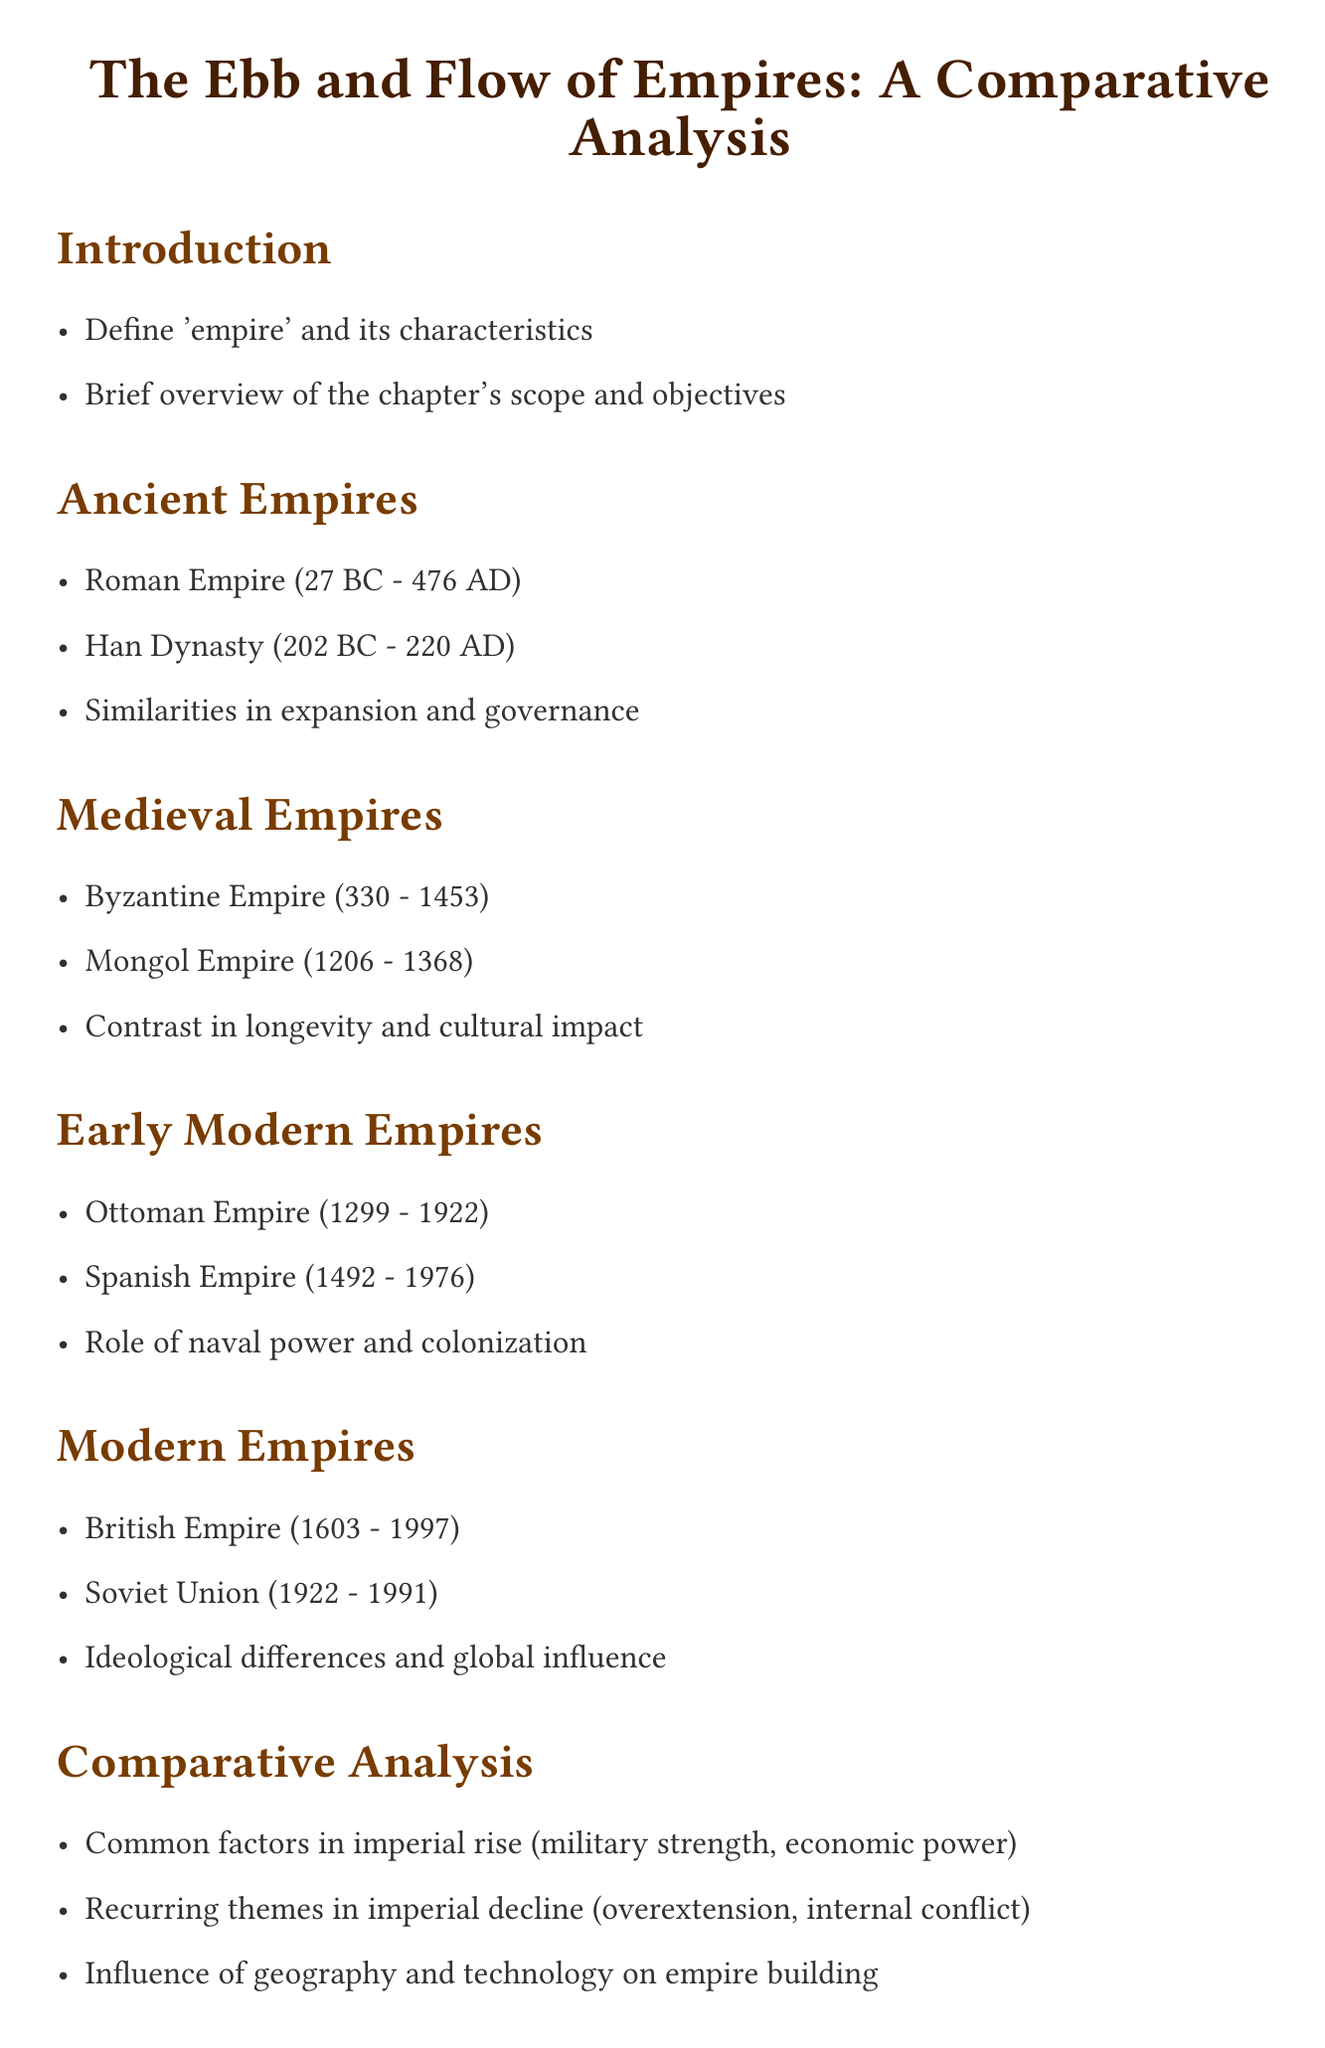What is the title of the chapter? The title is explicitly mentioned at the beginning of the document.
Answer: The Ebb and Flow of Empires: A Comparative Analysis What time period does the Roman Empire cover? The time period is detailed in the Ancient Empires section.
Answer: 27 BC - 476 AD Which empire is contrasted with the Mongol Empire? This is found in the Medieval Empires section, highlighting the differences explored in that section.
Answer: Byzantine Empire What were the years of the Ottoman Empire? The years of the Ottoman Empire are stated in the Early Modern Empires section.
Answer: 1299 - 1922 What are common factors in the rise of empires according to the comparative analysis? This information is taken from the Comparative Analysis section, summarizing key points.
Answer: Military strength, economic power What is one reason noted for imperial decline? This is mentioned in the Comparative Analysis section, describing themes commonly observed.
Answer: Overextension What lesson is highlighted in the conclusion of the chapter? This refers to the specific lessons drawn from historical empires as stated in the conclusion section.
Answer: Lessons from historical empires for modern geopolitics Which source discusses the decline and fall of the Roman Empire? The relevant sources list provides this information about one of the sources.
Answer: Gibbon, Edward. 'The History of the Decline and Fall of the Roman Empire' 